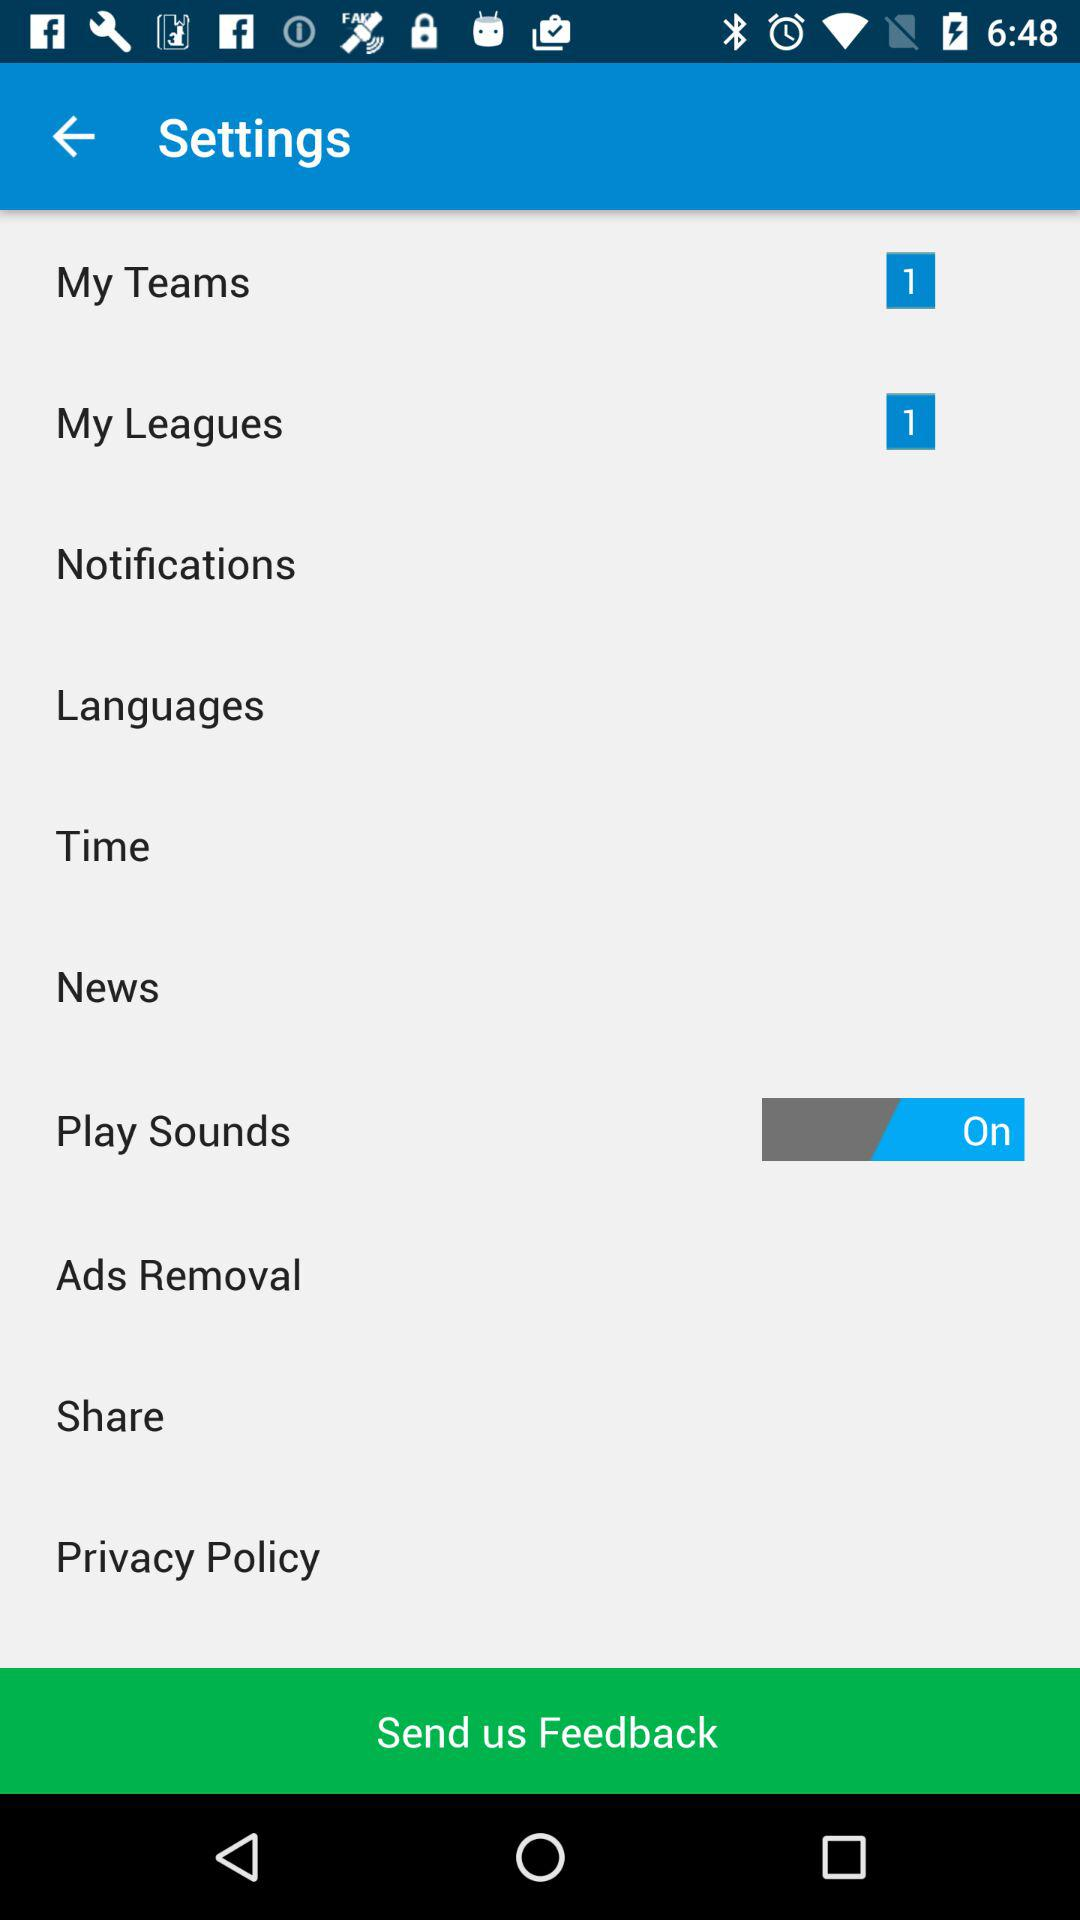How many new messages are present in the "My Teams" setting? There is 1 new message in the "My Teams" setting. 